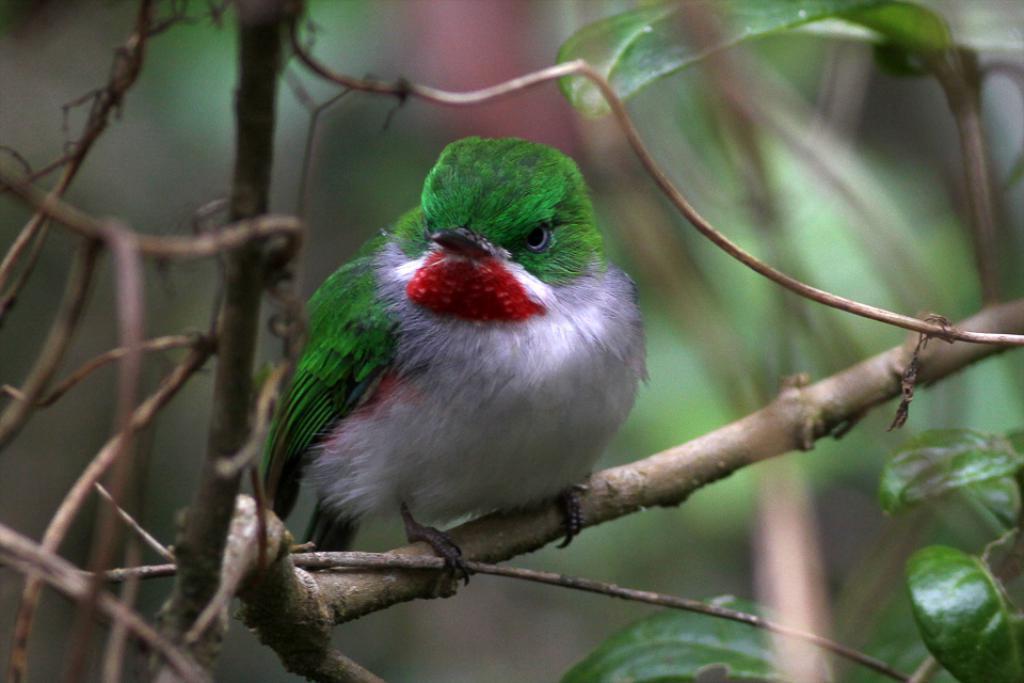Could you give a brief overview of what you see in this image? In this image we can see a bird on the tree branch. To the right side of the image there are leaves. The background of the image is blur. 